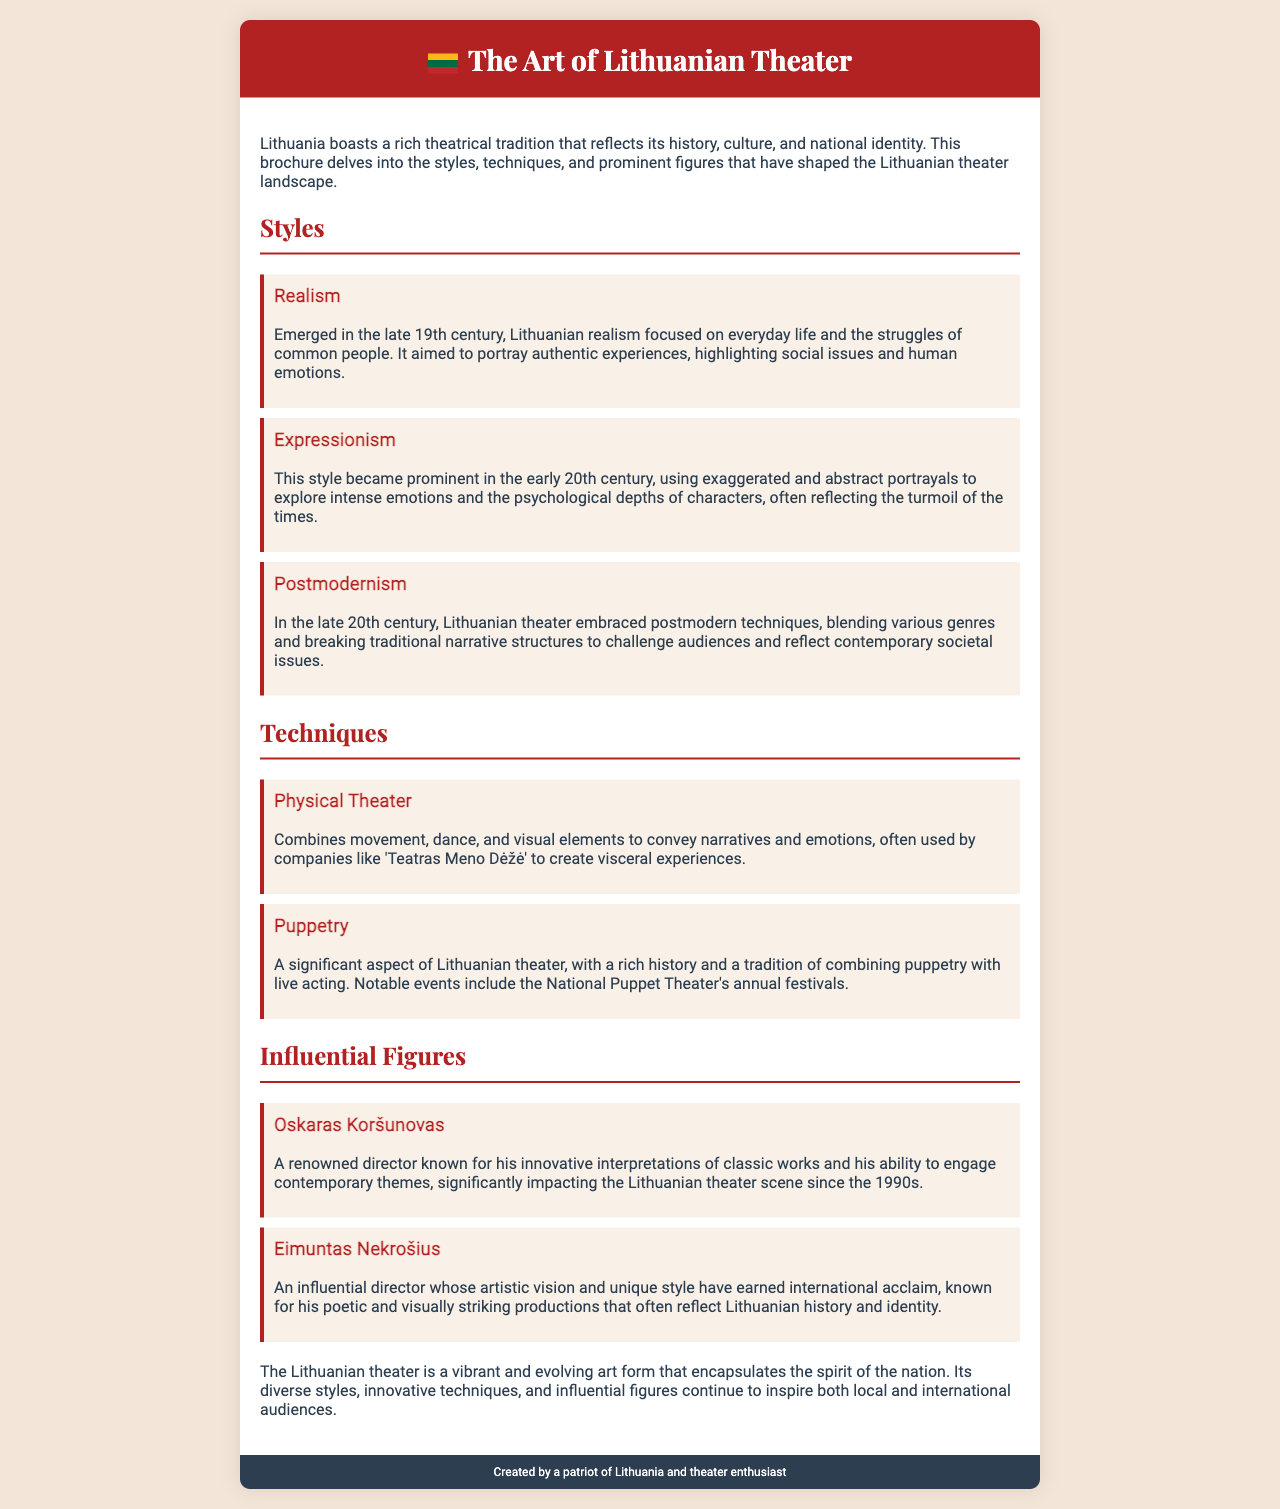What are the three main styles of Lithuanian theater? The document lists three styles: Realism, Expressionism, and Postmodernism.
Answer: Realism, Expressionism, Postmodernism Who is a renowned director known for innovative interpretations? The document specifies Oskaras Koršunovas as a renowned director known for innovative interpretations since the 1990s.
Answer: Oskaras Koršunovas What style focuses on everyday life and struggles of common people? The brochure describes Realism as focusing on everyday life and the struggles of common people.
Answer: Realism What technique combines movement, dance, and visual elements? The document states that Physical Theater combines movement, dance, and visual elements.
Answer: Physical Theater Which technique has a significant aspect in Lithuanian theater? The document highlights Puppetry as a significant aspect of Lithuanian theater.
Answer: Puppetry In what century did Expressionism become prominent? The brochure mentions that Expressionism became prominent in the early 20th century.
Answer: Early 20th century How does Postmodernism challenge audiences? The document explains Postmodernism blends various genres and breaks traditional narrative structures to challenge audiences.
Answer: Blending genres, breaking narratives What two directors are noted as influential figures? The brochure identifies Oskaras Koršunovas and Eimuntas Nekrošius as influential figures in Lithuanian theater.
Answer: Oskaras Koršunovas, Eimuntas Nekrošius What does the Lithuanian theater encapsulate? The document states that Lithuanian theater encapsulates the spirit of the nation.
Answer: Spirit of the nation 